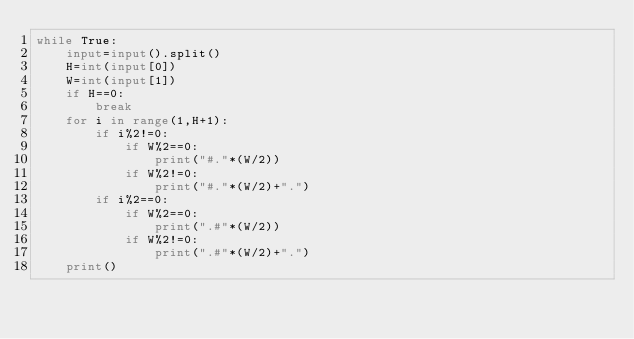Convert code to text. <code><loc_0><loc_0><loc_500><loc_500><_Python_>while True:
    input=input().split()
    H=int(input[0])
    W=int(input[1])
    if H==0:
        break
    for i in range(1,H+1):
        if i%2!=0:
            if W%2==0:
                print("#."*(W/2))
            if W%2!=0:
                print("#."*(W/2)+".")
        if i%2==0:
            if W%2==0:
                print(".#"*(W/2))
            if W%2!=0:
                print(".#"*(W/2)+".")
    print()
</code> 